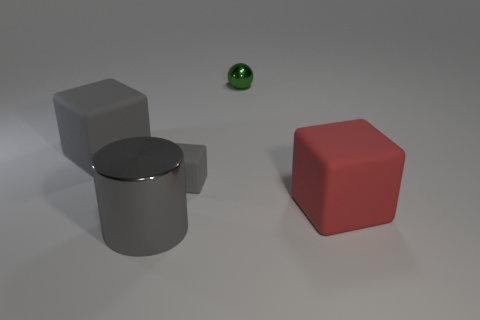What number of objects are either matte blocks in front of the tiny gray cube or gray objects?
Provide a short and direct response. 4. What number of things are both right of the small gray matte block and in front of the large gray rubber thing?
Offer a terse response. 1. What number of objects are large cubes on the right side of the big cylinder or big objects that are on the left side of the green object?
Ensure brevity in your answer.  3. What number of other objects are there of the same shape as the tiny rubber thing?
Offer a terse response. 2. There is a rubber block that is left of the tiny block; is its color the same as the big cylinder?
Ensure brevity in your answer.  Yes. What number of other objects are there of the same size as the green object?
Keep it short and to the point. 1. Is the material of the red cube the same as the tiny gray object?
Your answer should be very brief. Yes. The object that is behind the gray matte thing on the left side of the cylinder is what color?
Your answer should be very brief. Green. There is a red object that is the same shape as the tiny gray thing; what size is it?
Your answer should be very brief. Large. Does the tiny matte thing have the same color as the large metallic cylinder?
Give a very brief answer. Yes. 